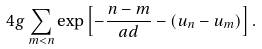Convert formula to latex. <formula><loc_0><loc_0><loc_500><loc_500>4 g \sum _ { m < n } \exp \left [ - \frac { n - m } { a d } - ( u _ { n } - u _ { m } ) \right ] .</formula> 